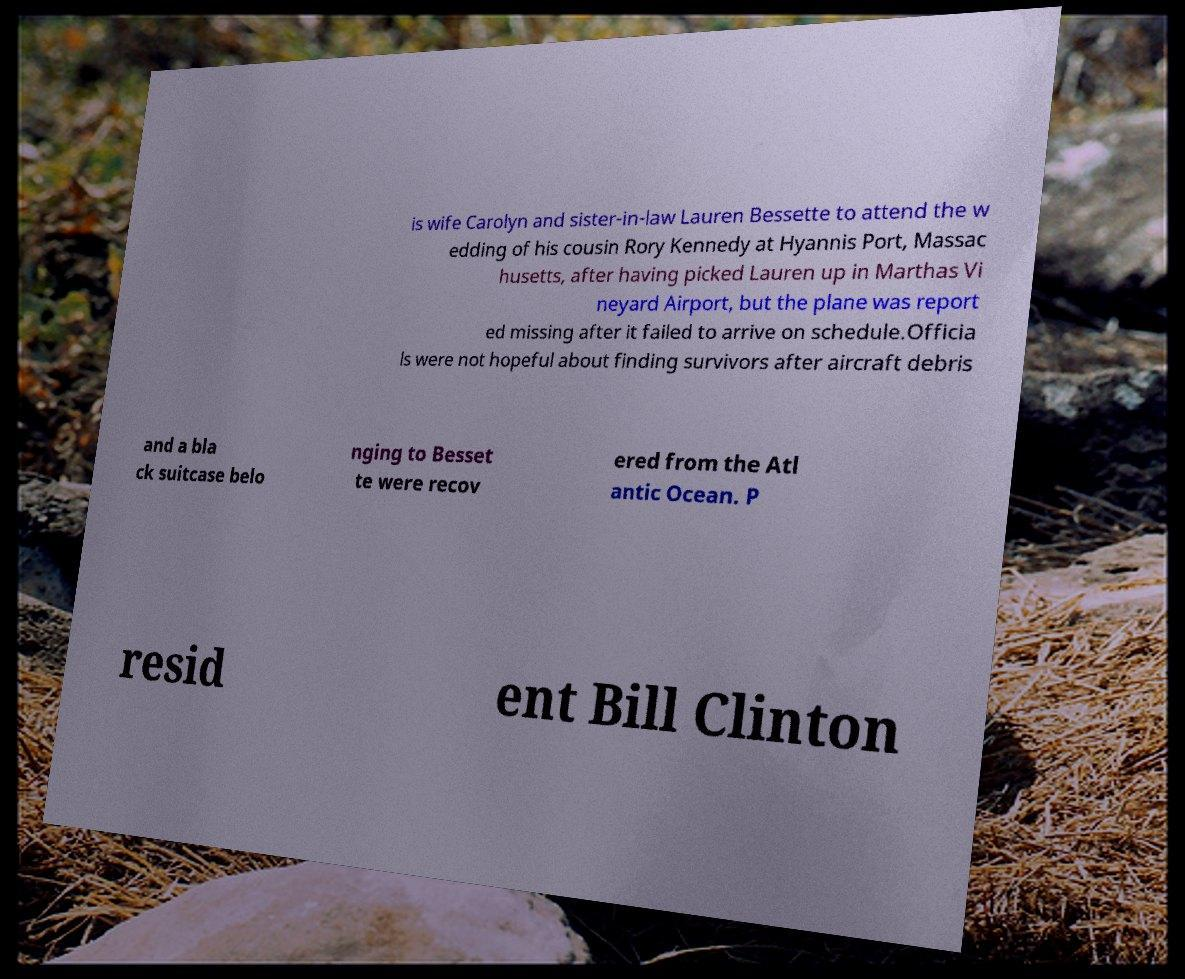Can you accurately transcribe the text from the provided image for me? is wife Carolyn and sister-in-law Lauren Bessette to attend the w edding of his cousin Rory Kennedy at Hyannis Port, Massac husetts, after having picked Lauren up in Marthas Vi neyard Airport, but the plane was report ed missing after it failed to arrive on schedule.Officia ls were not hopeful about finding survivors after aircraft debris and a bla ck suitcase belo nging to Besset te were recov ered from the Atl antic Ocean. P resid ent Bill Clinton 